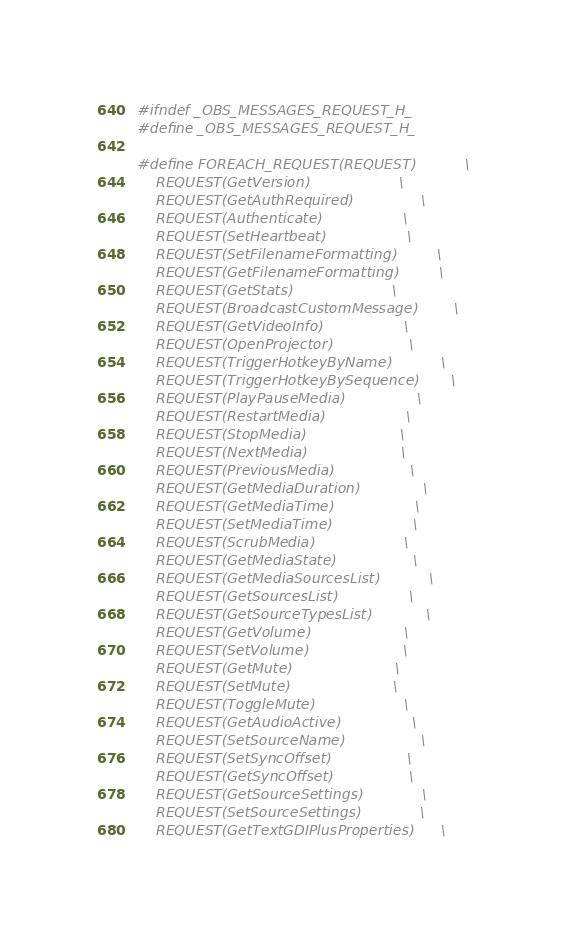Convert code to text. <code><loc_0><loc_0><loc_500><loc_500><_C_>#ifndef _OBS_MESSAGES_REQUEST_H_
#define _OBS_MESSAGES_REQUEST_H_

#define FOREACH_REQUEST(REQUEST)           \
    REQUEST(GetVersion)                    \
    REQUEST(GetAuthRequired)               \
    REQUEST(Authenticate)                  \
    REQUEST(SetHeartbeat)                  \
    REQUEST(SetFilenameFormatting)         \
    REQUEST(GetFilenameFormatting)         \
    REQUEST(GetStats)                      \
    REQUEST(BroadcastCustomMessage)        \
    REQUEST(GetVideoInfo)                  \
    REQUEST(OpenProjector)                 \
    REQUEST(TriggerHotkeyByName)           \
    REQUEST(TriggerHotkeyBySequence)       \
    REQUEST(PlayPauseMedia)                \
    REQUEST(RestartMedia)                  \
    REQUEST(StopMedia)                     \
    REQUEST(NextMedia)                     \
    REQUEST(PreviousMedia)                 \
    REQUEST(GetMediaDuration)              \
    REQUEST(GetMediaTime)                  \
    REQUEST(SetMediaTime)                  \
    REQUEST(ScrubMedia)                    \
    REQUEST(GetMediaState)                 \
    REQUEST(GetMediaSourcesList)           \
    REQUEST(GetSourcesList)                \
    REQUEST(GetSourceTypesList)            \
    REQUEST(GetVolume)                     \
    REQUEST(SetVolume)                     \
    REQUEST(GetMute)                       \
    REQUEST(SetMute)                       \
    REQUEST(ToggleMute)                    \
    REQUEST(GetAudioActive)                \
    REQUEST(SetSourceName)                 \
    REQUEST(SetSyncOffset)                 \
    REQUEST(GetSyncOffset)                 \
    REQUEST(GetSourceSettings)             \
    REQUEST(SetSourceSettings)             \
    REQUEST(GetTextGDIPlusProperties)      \</code> 